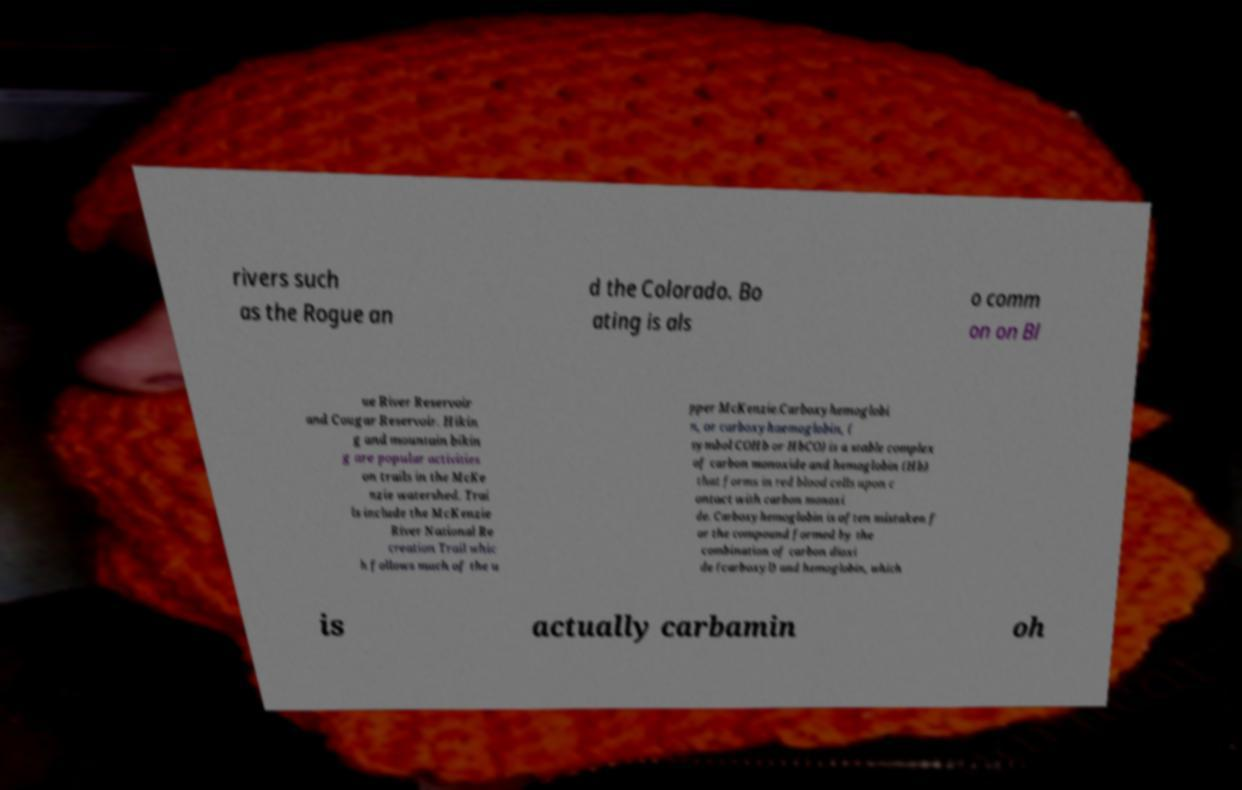Could you extract and type out the text from this image? rivers such as the Rogue an d the Colorado. Bo ating is als o comm on on Bl ue River Reservoir and Cougar Reservoir. Hikin g and mountain bikin g are popular activities on trails in the McKe nzie watershed. Trai ls include the McKenzie River National Re creation Trail whic h follows much of the u pper McKenzie.Carboxyhemoglobi n, or carboxyhaemoglobin, ( symbol COHb or HbCO) is a stable complex of carbon monoxide and hemoglobin (Hb) that forms in red blood cells upon c ontact with carbon monoxi de. Carboxyhemoglobin is often mistaken f or the compound formed by the combination of carbon dioxi de (carboxyl) and hemoglobin, which is actually carbamin oh 